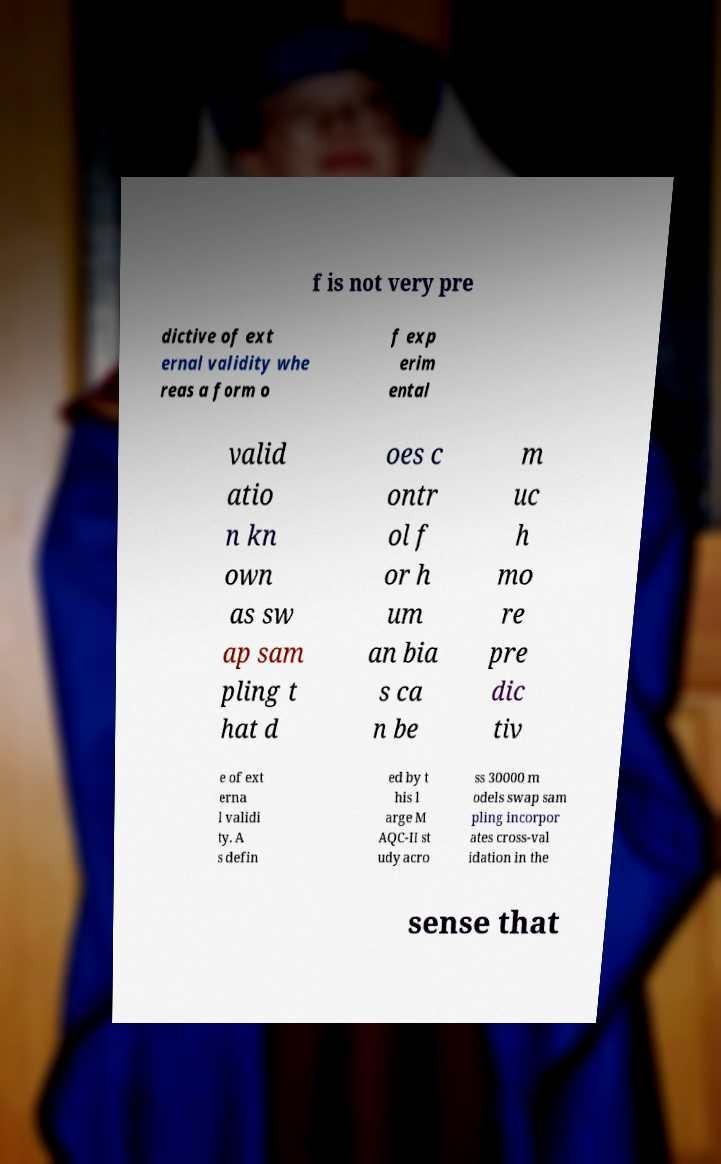For documentation purposes, I need the text within this image transcribed. Could you provide that? f is not very pre dictive of ext ernal validity whe reas a form o f exp erim ental valid atio n kn own as sw ap sam pling t hat d oes c ontr ol f or h um an bia s ca n be m uc h mo re pre dic tiv e of ext erna l validi ty. A s defin ed by t his l arge M AQC-II st udy acro ss 30000 m odels swap sam pling incorpor ates cross-val idation in the sense that 